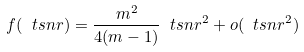<formula> <loc_0><loc_0><loc_500><loc_500>f ( \ t s n r ) = \frac { m ^ { 2 } } { 4 ( m - 1 ) } \ t s n r ^ { 2 } + o ( \ t s n r ^ { 2 } )</formula> 